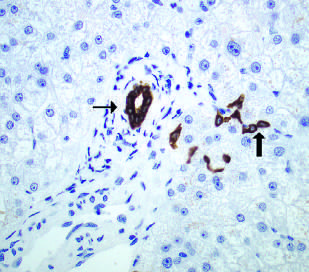re bile duct cells and canals of hering stained here with an immunohistochemical stain for cytokeratin 7?
Answer the question using a single word or phrase. Yes 